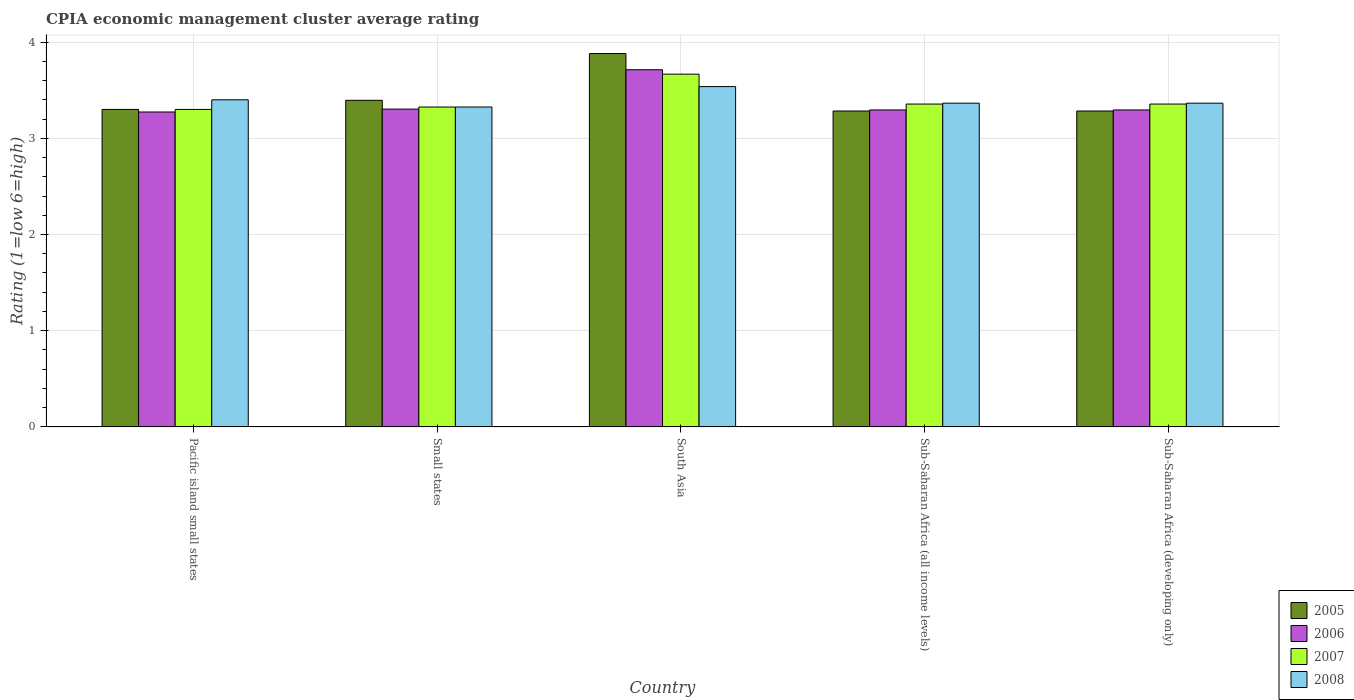Are the number of bars on each tick of the X-axis equal?
Your response must be concise. Yes. How many bars are there on the 3rd tick from the left?
Make the answer very short. 4. How many bars are there on the 3rd tick from the right?
Provide a succinct answer. 4. What is the label of the 1st group of bars from the left?
Your answer should be compact. Pacific island small states. What is the CPIA rating in 2006 in Sub-Saharan Africa (all income levels)?
Make the answer very short. 3.29. Across all countries, what is the maximum CPIA rating in 2007?
Offer a very short reply. 3.67. Across all countries, what is the minimum CPIA rating in 2007?
Your answer should be very brief. 3.3. In which country was the CPIA rating in 2006 minimum?
Your answer should be very brief. Pacific island small states. What is the total CPIA rating in 2008 in the graph?
Provide a short and direct response. 16.99. What is the difference between the CPIA rating in 2005 in Pacific island small states and that in Sub-Saharan Africa (all income levels)?
Make the answer very short. 0.02. What is the difference between the CPIA rating in 2007 in Sub-Saharan Africa (developing only) and the CPIA rating in 2008 in Pacific island small states?
Ensure brevity in your answer.  -0.04. What is the average CPIA rating in 2006 per country?
Your answer should be very brief. 3.38. What is the difference between the CPIA rating of/in 2008 and CPIA rating of/in 2007 in Sub-Saharan Africa (all income levels)?
Give a very brief answer. 0.01. What is the ratio of the CPIA rating in 2005 in Sub-Saharan Africa (all income levels) to that in Sub-Saharan Africa (developing only)?
Your answer should be very brief. 1. Is the difference between the CPIA rating in 2008 in Pacific island small states and Sub-Saharan Africa (all income levels) greater than the difference between the CPIA rating in 2007 in Pacific island small states and Sub-Saharan Africa (all income levels)?
Ensure brevity in your answer.  Yes. What is the difference between the highest and the second highest CPIA rating in 2008?
Your response must be concise. 0.04. What is the difference between the highest and the lowest CPIA rating in 2008?
Make the answer very short. 0.21. Is the sum of the CPIA rating in 2005 in Pacific island small states and Small states greater than the maximum CPIA rating in 2008 across all countries?
Provide a short and direct response. Yes. Is it the case that in every country, the sum of the CPIA rating in 2007 and CPIA rating in 2008 is greater than the sum of CPIA rating in 2005 and CPIA rating in 2006?
Offer a terse response. No. What does the 1st bar from the right in Sub-Saharan Africa (developing only) represents?
Your response must be concise. 2008. Are all the bars in the graph horizontal?
Your response must be concise. No. Are the values on the major ticks of Y-axis written in scientific E-notation?
Make the answer very short. No. Does the graph contain any zero values?
Your answer should be very brief. No. Where does the legend appear in the graph?
Your answer should be very brief. Bottom right. How many legend labels are there?
Provide a short and direct response. 4. How are the legend labels stacked?
Give a very brief answer. Vertical. What is the title of the graph?
Your answer should be very brief. CPIA economic management cluster average rating. What is the label or title of the Y-axis?
Your answer should be compact. Rating (1=low 6=high). What is the Rating (1=low 6=high) in 2005 in Pacific island small states?
Ensure brevity in your answer.  3.3. What is the Rating (1=low 6=high) of 2006 in Pacific island small states?
Give a very brief answer. 3.27. What is the Rating (1=low 6=high) in 2007 in Pacific island small states?
Offer a terse response. 3.3. What is the Rating (1=low 6=high) of 2008 in Pacific island small states?
Provide a short and direct response. 3.4. What is the Rating (1=low 6=high) in 2005 in Small states?
Make the answer very short. 3.39. What is the Rating (1=low 6=high) of 2006 in Small states?
Offer a terse response. 3.3. What is the Rating (1=low 6=high) in 2007 in Small states?
Provide a short and direct response. 3.33. What is the Rating (1=low 6=high) in 2008 in Small states?
Provide a short and direct response. 3.33. What is the Rating (1=low 6=high) of 2005 in South Asia?
Ensure brevity in your answer.  3.88. What is the Rating (1=low 6=high) of 2006 in South Asia?
Offer a terse response. 3.71. What is the Rating (1=low 6=high) in 2007 in South Asia?
Keep it short and to the point. 3.67. What is the Rating (1=low 6=high) of 2008 in South Asia?
Your response must be concise. 3.54. What is the Rating (1=low 6=high) of 2005 in Sub-Saharan Africa (all income levels)?
Your answer should be compact. 3.28. What is the Rating (1=low 6=high) of 2006 in Sub-Saharan Africa (all income levels)?
Ensure brevity in your answer.  3.29. What is the Rating (1=low 6=high) of 2007 in Sub-Saharan Africa (all income levels)?
Give a very brief answer. 3.36. What is the Rating (1=low 6=high) in 2008 in Sub-Saharan Africa (all income levels)?
Your answer should be compact. 3.36. What is the Rating (1=low 6=high) of 2005 in Sub-Saharan Africa (developing only)?
Ensure brevity in your answer.  3.28. What is the Rating (1=low 6=high) in 2006 in Sub-Saharan Africa (developing only)?
Make the answer very short. 3.29. What is the Rating (1=low 6=high) of 2007 in Sub-Saharan Africa (developing only)?
Ensure brevity in your answer.  3.36. What is the Rating (1=low 6=high) of 2008 in Sub-Saharan Africa (developing only)?
Your answer should be very brief. 3.36. Across all countries, what is the maximum Rating (1=low 6=high) in 2005?
Offer a very short reply. 3.88. Across all countries, what is the maximum Rating (1=low 6=high) of 2006?
Your answer should be compact. 3.71. Across all countries, what is the maximum Rating (1=low 6=high) of 2007?
Give a very brief answer. 3.67. Across all countries, what is the maximum Rating (1=low 6=high) of 2008?
Provide a short and direct response. 3.54. Across all countries, what is the minimum Rating (1=low 6=high) in 2005?
Your response must be concise. 3.28. Across all countries, what is the minimum Rating (1=low 6=high) of 2006?
Offer a terse response. 3.27. Across all countries, what is the minimum Rating (1=low 6=high) of 2007?
Give a very brief answer. 3.3. Across all countries, what is the minimum Rating (1=low 6=high) of 2008?
Give a very brief answer. 3.33. What is the total Rating (1=low 6=high) in 2005 in the graph?
Make the answer very short. 17.14. What is the total Rating (1=low 6=high) of 2006 in the graph?
Offer a very short reply. 16.88. What is the total Rating (1=low 6=high) in 2007 in the graph?
Keep it short and to the point. 17. What is the total Rating (1=low 6=high) of 2008 in the graph?
Ensure brevity in your answer.  16.99. What is the difference between the Rating (1=low 6=high) in 2005 in Pacific island small states and that in Small states?
Your answer should be very brief. -0.09. What is the difference between the Rating (1=low 6=high) of 2006 in Pacific island small states and that in Small states?
Provide a succinct answer. -0.03. What is the difference between the Rating (1=low 6=high) of 2007 in Pacific island small states and that in Small states?
Provide a succinct answer. -0.03. What is the difference between the Rating (1=low 6=high) of 2008 in Pacific island small states and that in Small states?
Keep it short and to the point. 0.07. What is the difference between the Rating (1=low 6=high) of 2005 in Pacific island small states and that in South Asia?
Give a very brief answer. -0.58. What is the difference between the Rating (1=low 6=high) of 2006 in Pacific island small states and that in South Asia?
Give a very brief answer. -0.44. What is the difference between the Rating (1=low 6=high) of 2007 in Pacific island small states and that in South Asia?
Keep it short and to the point. -0.37. What is the difference between the Rating (1=low 6=high) in 2008 in Pacific island small states and that in South Asia?
Offer a very short reply. -0.14. What is the difference between the Rating (1=low 6=high) of 2005 in Pacific island small states and that in Sub-Saharan Africa (all income levels)?
Offer a terse response. 0.02. What is the difference between the Rating (1=low 6=high) of 2006 in Pacific island small states and that in Sub-Saharan Africa (all income levels)?
Provide a short and direct response. -0.02. What is the difference between the Rating (1=low 6=high) in 2007 in Pacific island small states and that in Sub-Saharan Africa (all income levels)?
Offer a very short reply. -0.06. What is the difference between the Rating (1=low 6=high) of 2008 in Pacific island small states and that in Sub-Saharan Africa (all income levels)?
Provide a short and direct response. 0.04. What is the difference between the Rating (1=low 6=high) of 2005 in Pacific island small states and that in Sub-Saharan Africa (developing only)?
Give a very brief answer. 0.02. What is the difference between the Rating (1=low 6=high) in 2006 in Pacific island small states and that in Sub-Saharan Africa (developing only)?
Give a very brief answer. -0.02. What is the difference between the Rating (1=low 6=high) of 2007 in Pacific island small states and that in Sub-Saharan Africa (developing only)?
Your response must be concise. -0.06. What is the difference between the Rating (1=low 6=high) in 2008 in Pacific island small states and that in Sub-Saharan Africa (developing only)?
Make the answer very short. 0.04. What is the difference between the Rating (1=low 6=high) in 2005 in Small states and that in South Asia?
Provide a succinct answer. -0.49. What is the difference between the Rating (1=low 6=high) of 2006 in Small states and that in South Asia?
Provide a succinct answer. -0.41. What is the difference between the Rating (1=low 6=high) in 2007 in Small states and that in South Asia?
Provide a short and direct response. -0.34. What is the difference between the Rating (1=low 6=high) in 2008 in Small states and that in South Asia?
Provide a short and direct response. -0.21. What is the difference between the Rating (1=low 6=high) of 2005 in Small states and that in Sub-Saharan Africa (all income levels)?
Your answer should be compact. 0.11. What is the difference between the Rating (1=low 6=high) of 2006 in Small states and that in Sub-Saharan Africa (all income levels)?
Your answer should be compact. 0.01. What is the difference between the Rating (1=low 6=high) of 2007 in Small states and that in Sub-Saharan Africa (all income levels)?
Provide a short and direct response. -0.03. What is the difference between the Rating (1=low 6=high) in 2008 in Small states and that in Sub-Saharan Africa (all income levels)?
Make the answer very short. -0.04. What is the difference between the Rating (1=low 6=high) in 2005 in Small states and that in Sub-Saharan Africa (developing only)?
Give a very brief answer. 0.11. What is the difference between the Rating (1=low 6=high) in 2006 in Small states and that in Sub-Saharan Africa (developing only)?
Your response must be concise. 0.01. What is the difference between the Rating (1=low 6=high) of 2007 in Small states and that in Sub-Saharan Africa (developing only)?
Keep it short and to the point. -0.03. What is the difference between the Rating (1=low 6=high) of 2008 in Small states and that in Sub-Saharan Africa (developing only)?
Give a very brief answer. -0.04. What is the difference between the Rating (1=low 6=high) in 2005 in South Asia and that in Sub-Saharan Africa (all income levels)?
Provide a short and direct response. 0.6. What is the difference between the Rating (1=low 6=high) of 2006 in South Asia and that in Sub-Saharan Africa (all income levels)?
Offer a terse response. 0.42. What is the difference between the Rating (1=low 6=high) in 2007 in South Asia and that in Sub-Saharan Africa (all income levels)?
Offer a very short reply. 0.31. What is the difference between the Rating (1=low 6=high) in 2008 in South Asia and that in Sub-Saharan Africa (all income levels)?
Your answer should be compact. 0.17. What is the difference between the Rating (1=low 6=high) of 2005 in South Asia and that in Sub-Saharan Africa (developing only)?
Your answer should be very brief. 0.6. What is the difference between the Rating (1=low 6=high) of 2006 in South Asia and that in Sub-Saharan Africa (developing only)?
Make the answer very short. 0.42. What is the difference between the Rating (1=low 6=high) of 2007 in South Asia and that in Sub-Saharan Africa (developing only)?
Provide a short and direct response. 0.31. What is the difference between the Rating (1=low 6=high) of 2008 in South Asia and that in Sub-Saharan Africa (developing only)?
Provide a short and direct response. 0.17. What is the difference between the Rating (1=low 6=high) of 2005 in Sub-Saharan Africa (all income levels) and that in Sub-Saharan Africa (developing only)?
Make the answer very short. 0. What is the difference between the Rating (1=low 6=high) of 2008 in Sub-Saharan Africa (all income levels) and that in Sub-Saharan Africa (developing only)?
Ensure brevity in your answer.  0. What is the difference between the Rating (1=low 6=high) in 2005 in Pacific island small states and the Rating (1=low 6=high) in 2006 in Small states?
Offer a very short reply. -0. What is the difference between the Rating (1=low 6=high) of 2005 in Pacific island small states and the Rating (1=low 6=high) of 2007 in Small states?
Your answer should be very brief. -0.03. What is the difference between the Rating (1=low 6=high) of 2005 in Pacific island small states and the Rating (1=low 6=high) of 2008 in Small states?
Provide a succinct answer. -0.03. What is the difference between the Rating (1=low 6=high) in 2006 in Pacific island small states and the Rating (1=low 6=high) in 2007 in Small states?
Ensure brevity in your answer.  -0.05. What is the difference between the Rating (1=low 6=high) in 2006 in Pacific island small states and the Rating (1=low 6=high) in 2008 in Small states?
Your answer should be very brief. -0.05. What is the difference between the Rating (1=low 6=high) in 2007 in Pacific island small states and the Rating (1=low 6=high) in 2008 in Small states?
Give a very brief answer. -0.03. What is the difference between the Rating (1=low 6=high) of 2005 in Pacific island small states and the Rating (1=low 6=high) of 2006 in South Asia?
Your answer should be compact. -0.41. What is the difference between the Rating (1=low 6=high) of 2005 in Pacific island small states and the Rating (1=low 6=high) of 2007 in South Asia?
Make the answer very short. -0.37. What is the difference between the Rating (1=low 6=high) of 2005 in Pacific island small states and the Rating (1=low 6=high) of 2008 in South Asia?
Keep it short and to the point. -0.24. What is the difference between the Rating (1=low 6=high) in 2006 in Pacific island small states and the Rating (1=low 6=high) in 2007 in South Asia?
Provide a succinct answer. -0.39. What is the difference between the Rating (1=low 6=high) of 2006 in Pacific island small states and the Rating (1=low 6=high) of 2008 in South Asia?
Your answer should be very brief. -0.26. What is the difference between the Rating (1=low 6=high) in 2007 in Pacific island small states and the Rating (1=low 6=high) in 2008 in South Asia?
Give a very brief answer. -0.24. What is the difference between the Rating (1=low 6=high) of 2005 in Pacific island small states and the Rating (1=low 6=high) of 2006 in Sub-Saharan Africa (all income levels)?
Make the answer very short. 0.01. What is the difference between the Rating (1=low 6=high) in 2005 in Pacific island small states and the Rating (1=low 6=high) in 2007 in Sub-Saharan Africa (all income levels)?
Your answer should be compact. -0.06. What is the difference between the Rating (1=low 6=high) in 2005 in Pacific island small states and the Rating (1=low 6=high) in 2008 in Sub-Saharan Africa (all income levels)?
Give a very brief answer. -0.06. What is the difference between the Rating (1=low 6=high) in 2006 in Pacific island small states and the Rating (1=low 6=high) in 2007 in Sub-Saharan Africa (all income levels)?
Keep it short and to the point. -0.08. What is the difference between the Rating (1=low 6=high) in 2006 in Pacific island small states and the Rating (1=low 6=high) in 2008 in Sub-Saharan Africa (all income levels)?
Provide a short and direct response. -0.09. What is the difference between the Rating (1=low 6=high) in 2007 in Pacific island small states and the Rating (1=low 6=high) in 2008 in Sub-Saharan Africa (all income levels)?
Your answer should be very brief. -0.06. What is the difference between the Rating (1=low 6=high) in 2005 in Pacific island small states and the Rating (1=low 6=high) in 2006 in Sub-Saharan Africa (developing only)?
Your answer should be very brief. 0.01. What is the difference between the Rating (1=low 6=high) in 2005 in Pacific island small states and the Rating (1=low 6=high) in 2007 in Sub-Saharan Africa (developing only)?
Your answer should be compact. -0.06. What is the difference between the Rating (1=low 6=high) in 2005 in Pacific island small states and the Rating (1=low 6=high) in 2008 in Sub-Saharan Africa (developing only)?
Provide a succinct answer. -0.06. What is the difference between the Rating (1=low 6=high) of 2006 in Pacific island small states and the Rating (1=low 6=high) of 2007 in Sub-Saharan Africa (developing only)?
Provide a succinct answer. -0.08. What is the difference between the Rating (1=low 6=high) of 2006 in Pacific island small states and the Rating (1=low 6=high) of 2008 in Sub-Saharan Africa (developing only)?
Give a very brief answer. -0.09. What is the difference between the Rating (1=low 6=high) of 2007 in Pacific island small states and the Rating (1=low 6=high) of 2008 in Sub-Saharan Africa (developing only)?
Your answer should be compact. -0.06. What is the difference between the Rating (1=low 6=high) of 2005 in Small states and the Rating (1=low 6=high) of 2006 in South Asia?
Your response must be concise. -0.32. What is the difference between the Rating (1=low 6=high) of 2005 in Small states and the Rating (1=low 6=high) of 2007 in South Asia?
Keep it short and to the point. -0.27. What is the difference between the Rating (1=low 6=high) in 2005 in Small states and the Rating (1=low 6=high) in 2008 in South Asia?
Offer a terse response. -0.14. What is the difference between the Rating (1=low 6=high) of 2006 in Small states and the Rating (1=low 6=high) of 2007 in South Asia?
Provide a short and direct response. -0.36. What is the difference between the Rating (1=low 6=high) in 2006 in Small states and the Rating (1=low 6=high) in 2008 in South Asia?
Ensure brevity in your answer.  -0.23. What is the difference between the Rating (1=low 6=high) in 2007 in Small states and the Rating (1=low 6=high) in 2008 in South Asia?
Provide a succinct answer. -0.21. What is the difference between the Rating (1=low 6=high) of 2005 in Small states and the Rating (1=low 6=high) of 2006 in Sub-Saharan Africa (all income levels)?
Keep it short and to the point. 0.1. What is the difference between the Rating (1=low 6=high) of 2005 in Small states and the Rating (1=low 6=high) of 2007 in Sub-Saharan Africa (all income levels)?
Your answer should be very brief. 0.04. What is the difference between the Rating (1=low 6=high) of 2005 in Small states and the Rating (1=low 6=high) of 2008 in Sub-Saharan Africa (all income levels)?
Offer a very short reply. 0.03. What is the difference between the Rating (1=low 6=high) in 2006 in Small states and the Rating (1=low 6=high) in 2007 in Sub-Saharan Africa (all income levels)?
Your response must be concise. -0.05. What is the difference between the Rating (1=low 6=high) of 2006 in Small states and the Rating (1=low 6=high) of 2008 in Sub-Saharan Africa (all income levels)?
Your answer should be very brief. -0.06. What is the difference between the Rating (1=low 6=high) of 2007 in Small states and the Rating (1=low 6=high) of 2008 in Sub-Saharan Africa (all income levels)?
Your response must be concise. -0.04. What is the difference between the Rating (1=low 6=high) of 2005 in Small states and the Rating (1=low 6=high) of 2006 in Sub-Saharan Africa (developing only)?
Ensure brevity in your answer.  0.1. What is the difference between the Rating (1=low 6=high) of 2005 in Small states and the Rating (1=low 6=high) of 2007 in Sub-Saharan Africa (developing only)?
Make the answer very short. 0.04. What is the difference between the Rating (1=low 6=high) in 2005 in Small states and the Rating (1=low 6=high) in 2008 in Sub-Saharan Africa (developing only)?
Ensure brevity in your answer.  0.03. What is the difference between the Rating (1=low 6=high) of 2006 in Small states and the Rating (1=low 6=high) of 2007 in Sub-Saharan Africa (developing only)?
Make the answer very short. -0.05. What is the difference between the Rating (1=low 6=high) in 2006 in Small states and the Rating (1=low 6=high) in 2008 in Sub-Saharan Africa (developing only)?
Provide a short and direct response. -0.06. What is the difference between the Rating (1=low 6=high) of 2007 in Small states and the Rating (1=low 6=high) of 2008 in Sub-Saharan Africa (developing only)?
Ensure brevity in your answer.  -0.04. What is the difference between the Rating (1=low 6=high) in 2005 in South Asia and the Rating (1=low 6=high) in 2006 in Sub-Saharan Africa (all income levels)?
Your answer should be very brief. 0.59. What is the difference between the Rating (1=low 6=high) in 2005 in South Asia and the Rating (1=low 6=high) in 2007 in Sub-Saharan Africa (all income levels)?
Give a very brief answer. 0.53. What is the difference between the Rating (1=low 6=high) in 2005 in South Asia and the Rating (1=low 6=high) in 2008 in Sub-Saharan Africa (all income levels)?
Provide a short and direct response. 0.52. What is the difference between the Rating (1=low 6=high) in 2006 in South Asia and the Rating (1=low 6=high) in 2007 in Sub-Saharan Africa (all income levels)?
Your answer should be very brief. 0.36. What is the difference between the Rating (1=low 6=high) in 2006 in South Asia and the Rating (1=low 6=high) in 2008 in Sub-Saharan Africa (all income levels)?
Provide a short and direct response. 0.35. What is the difference between the Rating (1=low 6=high) in 2007 in South Asia and the Rating (1=low 6=high) in 2008 in Sub-Saharan Africa (all income levels)?
Provide a short and direct response. 0.3. What is the difference between the Rating (1=low 6=high) in 2005 in South Asia and the Rating (1=low 6=high) in 2006 in Sub-Saharan Africa (developing only)?
Ensure brevity in your answer.  0.59. What is the difference between the Rating (1=low 6=high) in 2005 in South Asia and the Rating (1=low 6=high) in 2007 in Sub-Saharan Africa (developing only)?
Provide a succinct answer. 0.53. What is the difference between the Rating (1=low 6=high) of 2005 in South Asia and the Rating (1=low 6=high) of 2008 in Sub-Saharan Africa (developing only)?
Offer a very short reply. 0.52. What is the difference between the Rating (1=low 6=high) in 2006 in South Asia and the Rating (1=low 6=high) in 2007 in Sub-Saharan Africa (developing only)?
Provide a succinct answer. 0.36. What is the difference between the Rating (1=low 6=high) of 2006 in South Asia and the Rating (1=low 6=high) of 2008 in Sub-Saharan Africa (developing only)?
Keep it short and to the point. 0.35. What is the difference between the Rating (1=low 6=high) in 2007 in South Asia and the Rating (1=low 6=high) in 2008 in Sub-Saharan Africa (developing only)?
Give a very brief answer. 0.3. What is the difference between the Rating (1=low 6=high) of 2005 in Sub-Saharan Africa (all income levels) and the Rating (1=low 6=high) of 2006 in Sub-Saharan Africa (developing only)?
Ensure brevity in your answer.  -0.01. What is the difference between the Rating (1=low 6=high) in 2005 in Sub-Saharan Africa (all income levels) and the Rating (1=low 6=high) in 2007 in Sub-Saharan Africa (developing only)?
Your answer should be very brief. -0.07. What is the difference between the Rating (1=low 6=high) of 2005 in Sub-Saharan Africa (all income levels) and the Rating (1=low 6=high) of 2008 in Sub-Saharan Africa (developing only)?
Make the answer very short. -0.08. What is the difference between the Rating (1=low 6=high) of 2006 in Sub-Saharan Africa (all income levels) and the Rating (1=low 6=high) of 2007 in Sub-Saharan Africa (developing only)?
Provide a short and direct response. -0.06. What is the difference between the Rating (1=low 6=high) of 2006 in Sub-Saharan Africa (all income levels) and the Rating (1=low 6=high) of 2008 in Sub-Saharan Africa (developing only)?
Keep it short and to the point. -0.07. What is the difference between the Rating (1=low 6=high) of 2007 in Sub-Saharan Africa (all income levels) and the Rating (1=low 6=high) of 2008 in Sub-Saharan Africa (developing only)?
Your answer should be compact. -0.01. What is the average Rating (1=low 6=high) of 2005 per country?
Offer a terse response. 3.43. What is the average Rating (1=low 6=high) of 2006 per country?
Your response must be concise. 3.38. What is the average Rating (1=low 6=high) of 2007 per country?
Keep it short and to the point. 3.4. What is the average Rating (1=low 6=high) of 2008 per country?
Provide a succinct answer. 3.4. What is the difference between the Rating (1=low 6=high) in 2005 and Rating (1=low 6=high) in 2006 in Pacific island small states?
Your answer should be compact. 0.03. What is the difference between the Rating (1=low 6=high) of 2005 and Rating (1=low 6=high) of 2007 in Pacific island small states?
Make the answer very short. 0. What is the difference between the Rating (1=low 6=high) of 2006 and Rating (1=low 6=high) of 2007 in Pacific island small states?
Offer a very short reply. -0.03. What is the difference between the Rating (1=low 6=high) of 2006 and Rating (1=low 6=high) of 2008 in Pacific island small states?
Give a very brief answer. -0.13. What is the difference between the Rating (1=low 6=high) in 2007 and Rating (1=low 6=high) in 2008 in Pacific island small states?
Ensure brevity in your answer.  -0.1. What is the difference between the Rating (1=low 6=high) in 2005 and Rating (1=low 6=high) in 2006 in Small states?
Offer a terse response. 0.09. What is the difference between the Rating (1=low 6=high) in 2005 and Rating (1=low 6=high) in 2007 in Small states?
Offer a very short reply. 0.07. What is the difference between the Rating (1=low 6=high) in 2005 and Rating (1=low 6=high) in 2008 in Small states?
Keep it short and to the point. 0.07. What is the difference between the Rating (1=low 6=high) in 2006 and Rating (1=low 6=high) in 2007 in Small states?
Provide a succinct answer. -0.02. What is the difference between the Rating (1=low 6=high) of 2006 and Rating (1=low 6=high) of 2008 in Small states?
Your answer should be very brief. -0.02. What is the difference between the Rating (1=low 6=high) in 2007 and Rating (1=low 6=high) in 2008 in Small states?
Provide a short and direct response. 0. What is the difference between the Rating (1=low 6=high) of 2005 and Rating (1=low 6=high) of 2006 in South Asia?
Give a very brief answer. 0.17. What is the difference between the Rating (1=low 6=high) in 2005 and Rating (1=low 6=high) in 2007 in South Asia?
Make the answer very short. 0.21. What is the difference between the Rating (1=low 6=high) in 2005 and Rating (1=low 6=high) in 2008 in South Asia?
Your response must be concise. 0.34. What is the difference between the Rating (1=low 6=high) of 2006 and Rating (1=low 6=high) of 2007 in South Asia?
Make the answer very short. 0.05. What is the difference between the Rating (1=low 6=high) of 2006 and Rating (1=low 6=high) of 2008 in South Asia?
Your response must be concise. 0.17. What is the difference between the Rating (1=low 6=high) of 2007 and Rating (1=low 6=high) of 2008 in South Asia?
Your answer should be compact. 0.13. What is the difference between the Rating (1=low 6=high) of 2005 and Rating (1=low 6=high) of 2006 in Sub-Saharan Africa (all income levels)?
Offer a terse response. -0.01. What is the difference between the Rating (1=low 6=high) of 2005 and Rating (1=low 6=high) of 2007 in Sub-Saharan Africa (all income levels)?
Provide a succinct answer. -0.07. What is the difference between the Rating (1=low 6=high) in 2005 and Rating (1=low 6=high) in 2008 in Sub-Saharan Africa (all income levels)?
Keep it short and to the point. -0.08. What is the difference between the Rating (1=low 6=high) of 2006 and Rating (1=low 6=high) of 2007 in Sub-Saharan Africa (all income levels)?
Offer a very short reply. -0.06. What is the difference between the Rating (1=low 6=high) in 2006 and Rating (1=low 6=high) in 2008 in Sub-Saharan Africa (all income levels)?
Keep it short and to the point. -0.07. What is the difference between the Rating (1=low 6=high) of 2007 and Rating (1=low 6=high) of 2008 in Sub-Saharan Africa (all income levels)?
Give a very brief answer. -0.01. What is the difference between the Rating (1=low 6=high) in 2005 and Rating (1=low 6=high) in 2006 in Sub-Saharan Africa (developing only)?
Give a very brief answer. -0.01. What is the difference between the Rating (1=low 6=high) of 2005 and Rating (1=low 6=high) of 2007 in Sub-Saharan Africa (developing only)?
Provide a succinct answer. -0.07. What is the difference between the Rating (1=low 6=high) of 2005 and Rating (1=low 6=high) of 2008 in Sub-Saharan Africa (developing only)?
Ensure brevity in your answer.  -0.08. What is the difference between the Rating (1=low 6=high) in 2006 and Rating (1=low 6=high) in 2007 in Sub-Saharan Africa (developing only)?
Offer a very short reply. -0.06. What is the difference between the Rating (1=low 6=high) in 2006 and Rating (1=low 6=high) in 2008 in Sub-Saharan Africa (developing only)?
Make the answer very short. -0.07. What is the difference between the Rating (1=low 6=high) in 2007 and Rating (1=low 6=high) in 2008 in Sub-Saharan Africa (developing only)?
Offer a terse response. -0.01. What is the ratio of the Rating (1=low 6=high) of 2005 in Pacific island small states to that in Small states?
Your answer should be compact. 0.97. What is the ratio of the Rating (1=low 6=high) of 2006 in Pacific island small states to that in Small states?
Ensure brevity in your answer.  0.99. What is the ratio of the Rating (1=low 6=high) in 2007 in Pacific island small states to that in Small states?
Your answer should be very brief. 0.99. What is the ratio of the Rating (1=low 6=high) of 2008 in Pacific island small states to that in Small states?
Your answer should be very brief. 1.02. What is the ratio of the Rating (1=low 6=high) of 2005 in Pacific island small states to that in South Asia?
Provide a succinct answer. 0.85. What is the ratio of the Rating (1=low 6=high) in 2006 in Pacific island small states to that in South Asia?
Your answer should be compact. 0.88. What is the ratio of the Rating (1=low 6=high) in 2008 in Pacific island small states to that in South Asia?
Offer a very short reply. 0.96. What is the ratio of the Rating (1=low 6=high) of 2007 in Pacific island small states to that in Sub-Saharan Africa (all income levels)?
Keep it short and to the point. 0.98. What is the ratio of the Rating (1=low 6=high) in 2008 in Pacific island small states to that in Sub-Saharan Africa (all income levels)?
Make the answer very short. 1.01. What is the ratio of the Rating (1=low 6=high) of 2005 in Pacific island small states to that in Sub-Saharan Africa (developing only)?
Make the answer very short. 1. What is the ratio of the Rating (1=low 6=high) of 2007 in Pacific island small states to that in Sub-Saharan Africa (developing only)?
Your answer should be compact. 0.98. What is the ratio of the Rating (1=low 6=high) in 2008 in Pacific island small states to that in Sub-Saharan Africa (developing only)?
Your answer should be compact. 1.01. What is the ratio of the Rating (1=low 6=high) of 2005 in Small states to that in South Asia?
Your response must be concise. 0.87. What is the ratio of the Rating (1=low 6=high) in 2006 in Small states to that in South Asia?
Provide a short and direct response. 0.89. What is the ratio of the Rating (1=low 6=high) of 2007 in Small states to that in South Asia?
Your answer should be compact. 0.91. What is the ratio of the Rating (1=low 6=high) in 2008 in Small states to that in South Asia?
Your response must be concise. 0.94. What is the ratio of the Rating (1=low 6=high) of 2005 in Small states to that in Sub-Saharan Africa (all income levels)?
Ensure brevity in your answer.  1.03. What is the ratio of the Rating (1=low 6=high) of 2006 in Small states to that in Sub-Saharan Africa (all income levels)?
Give a very brief answer. 1. What is the ratio of the Rating (1=low 6=high) of 2008 in Small states to that in Sub-Saharan Africa (all income levels)?
Offer a very short reply. 0.99. What is the ratio of the Rating (1=low 6=high) of 2005 in Small states to that in Sub-Saharan Africa (developing only)?
Keep it short and to the point. 1.03. What is the ratio of the Rating (1=low 6=high) of 2007 in Small states to that in Sub-Saharan Africa (developing only)?
Give a very brief answer. 0.99. What is the ratio of the Rating (1=low 6=high) of 2008 in Small states to that in Sub-Saharan Africa (developing only)?
Your answer should be very brief. 0.99. What is the ratio of the Rating (1=low 6=high) of 2005 in South Asia to that in Sub-Saharan Africa (all income levels)?
Ensure brevity in your answer.  1.18. What is the ratio of the Rating (1=low 6=high) of 2006 in South Asia to that in Sub-Saharan Africa (all income levels)?
Your answer should be compact. 1.13. What is the ratio of the Rating (1=low 6=high) in 2007 in South Asia to that in Sub-Saharan Africa (all income levels)?
Provide a short and direct response. 1.09. What is the ratio of the Rating (1=low 6=high) in 2008 in South Asia to that in Sub-Saharan Africa (all income levels)?
Give a very brief answer. 1.05. What is the ratio of the Rating (1=low 6=high) in 2005 in South Asia to that in Sub-Saharan Africa (developing only)?
Provide a succinct answer. 1.18. What is the ratio of the Rating (1=low 6=high) in 2006 in South Asia to that in Sub-Saharan Africa (developing only)?
Your answer should be compact. 1.13. What is the ratio of the Rating (1=low 6=high) in 2007 in South Asia to that in Sub-Saharan Africa (developing only)?
Ensure brevity in your answer.  1.09. What is the ratio of the Rating (1=low 6=high) in 2008 in South Asia to that in Sub-Saharan Africa (developing only)?
Keep it short and to the point. 1.05. What is the ratio of the Rating (1=low 6=high) of 2005 in Sub-Saharan Africa (all income levels) to that in Sub-Saharan Africa (developing only)?
Ensure brevity in your answer.  1. What is the difference between the highest and the second highest Rating (1=low 6=high) of 2005?
Your answer should be compact. 0.49. What is the difference between the highest and the second highest Rating (1=low 6=high) in 2006?
Keep it short and to the point. 0.41. What is the difference between the highest and the second highest Rating (1=low 6=high) of 2007?
Make the answer very short. 0.31. What is the difference between the highest and the second highest Rating (1=low 6=high) of 2008?
Make the answer very short. 0.14. What is the difference between the highest and the lowest Rating (1=low 6=high) in 2005?
Offer a very short reply. 0.6. What is the difference between the highest and the lowest Rating (1=low 6=high) of 2006?
Provide a short and direct response. 0.44. What is the difference between the highest and the lowest Rating (1=low 6=high) of 2007?
Your answer should be very brief. 0.37. What is the difference between the highest and the lowest Rating (1=low 6=high) in 2008?
Make the answer very short. 0.21. 